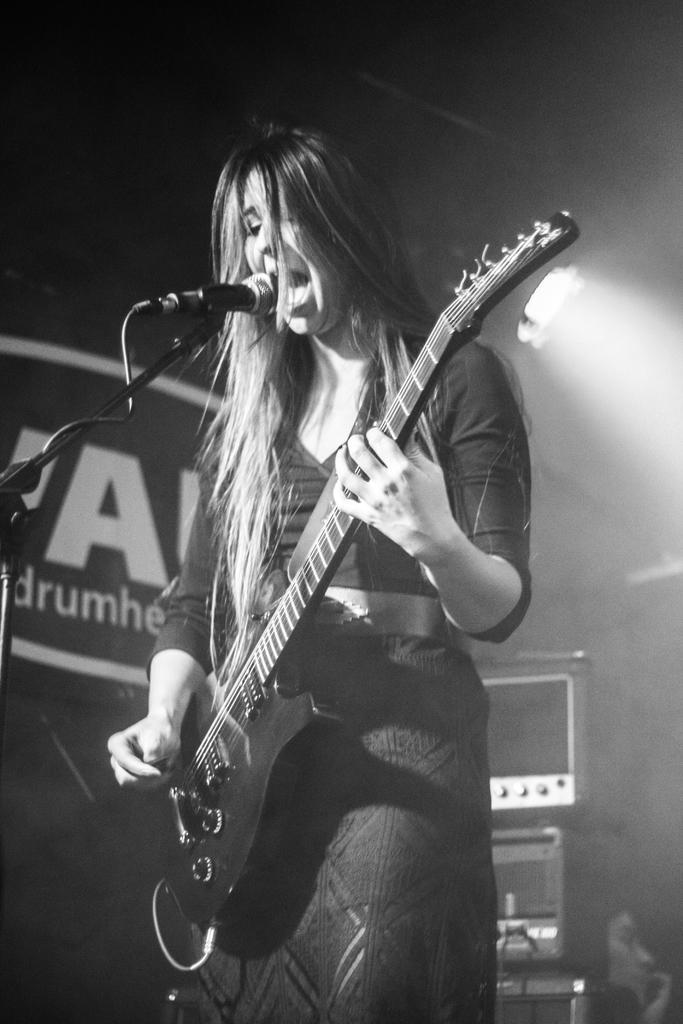Can you describe this image briefly? In this image there is a woman standing and playing a guitar , singing a song in the microphone, in the back ground there is a speaker and light. 